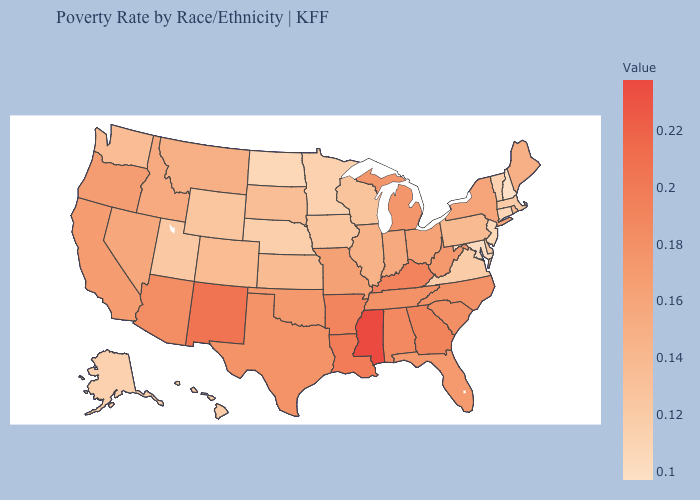Which states have the lowest value in the USA?
Give a very brief answer. New Hampshire. Does Texas have a higher value than Connecticut?
Keep it brief. Yes. Does Mississippi have the highest value in the USA?
Concise answer only. Yes. Is the legend a continuous bar?
Concise answer only. Yes. Among the states that border South Carolina , which have the lowest value?
Short answer required. North Carolina. Is the legend a continuous bar?
Concise answer only. Yes. Which states hav the highest value in the MidWest?
Write a very short answer. Michigan. Which states have the highest value in the USA?
Keep it brief. Mississippi. 